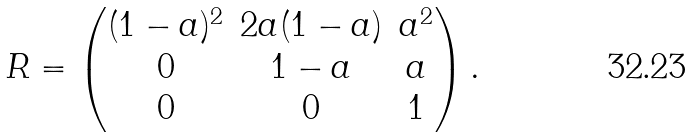Convert formula to latex. <formula><loc_0><loc_0><loc_500><loc_500>R = \begin{pmatrix} ( 1 - a ) ^ { 2 } & 2 a ( 1 - a ) & a ^ { 2 } \\ 0 & 1 - a & a \\ 0 & 0 & 1 \end{pmatrix} .</formula> 